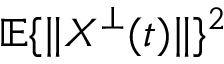<formula> <loc_0><loc_0><loc_500><loc_500>\mathbb { E } \{ \| X ^ { \bot } ( t ) \| \} ^ { 2 }</formula> 